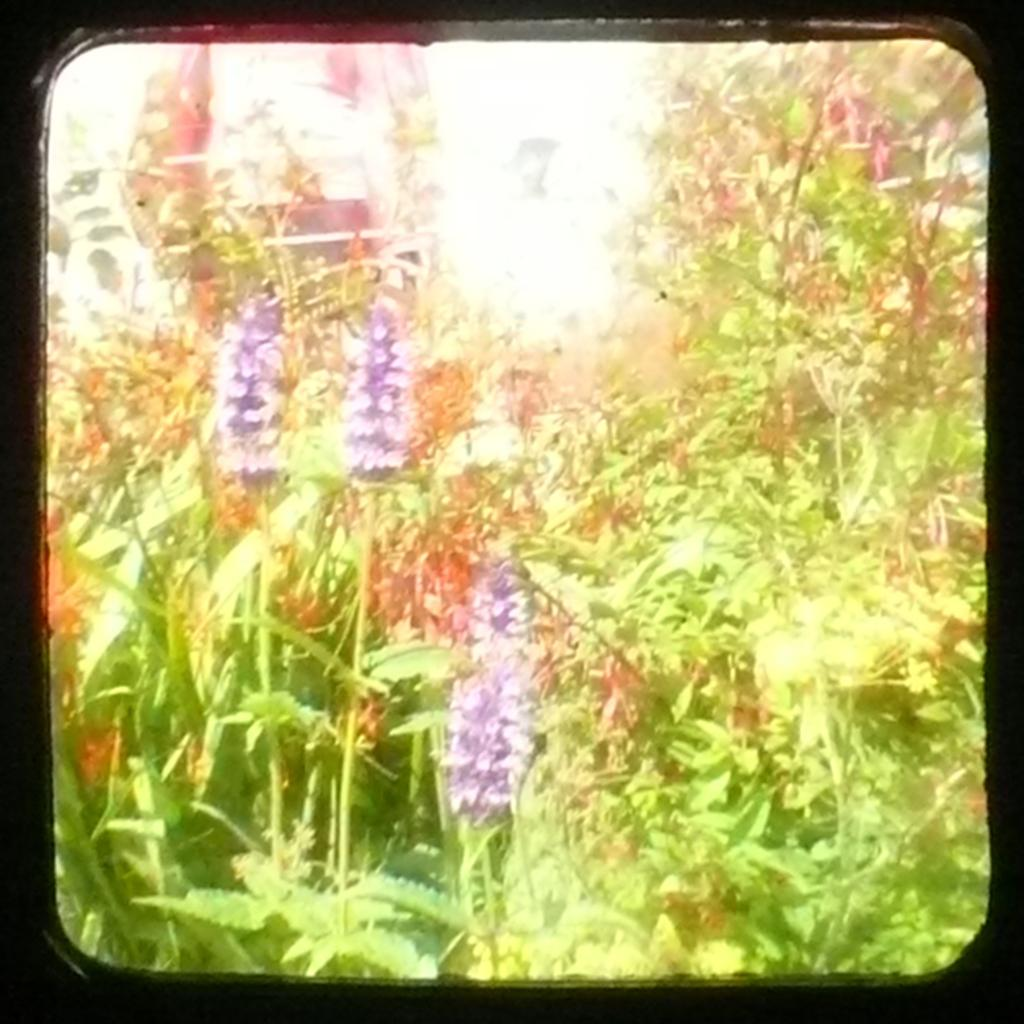What types of living organisms are in the image? The image contains plants and flowers. Can you describe the lighting in the image? There is light in the image. How is the image framed? The image has a black border. What type of coal is being used to sweeten the honey in the image? There is no coal or honey present in the image; it features plants and flowers. 